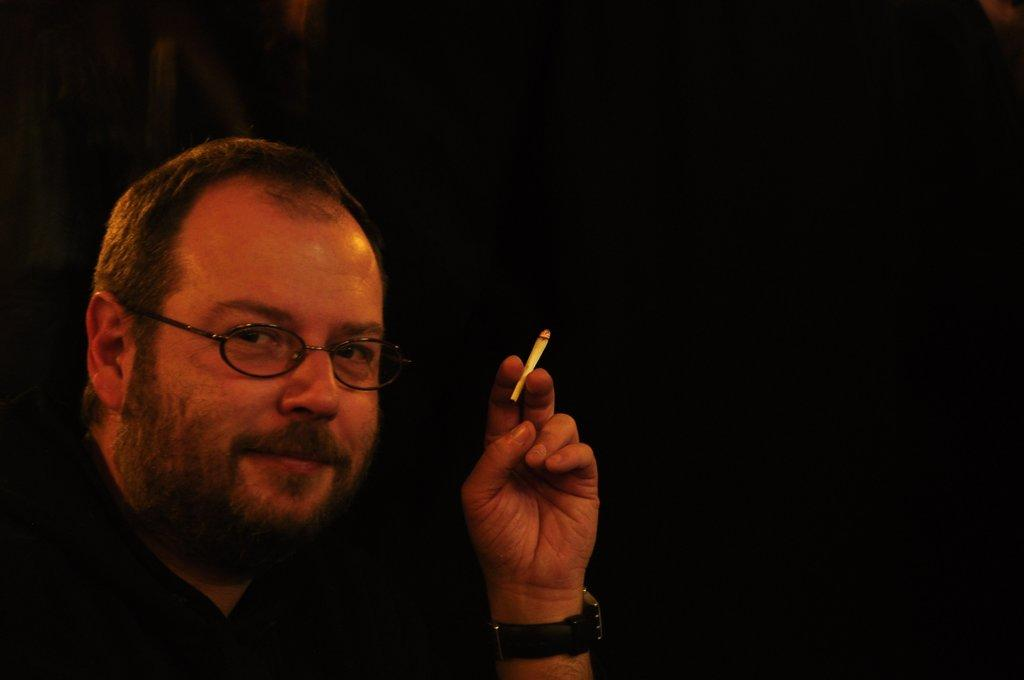What is the main subject of the image? There is a person in the image. What is the person holding in his hand? The person is holding a cigarette in his hand. Can you describe the person's appearance? The person is wearing spectacles. What is the person's facial expression? The person is smiling. What can be observed about the background of the image? The background of the image is dark. Is there any glue visible in the image? No, there is no glue present in the image. Can you see any snow or a stream in the image? No, there is no snow or stream visible in the image. 